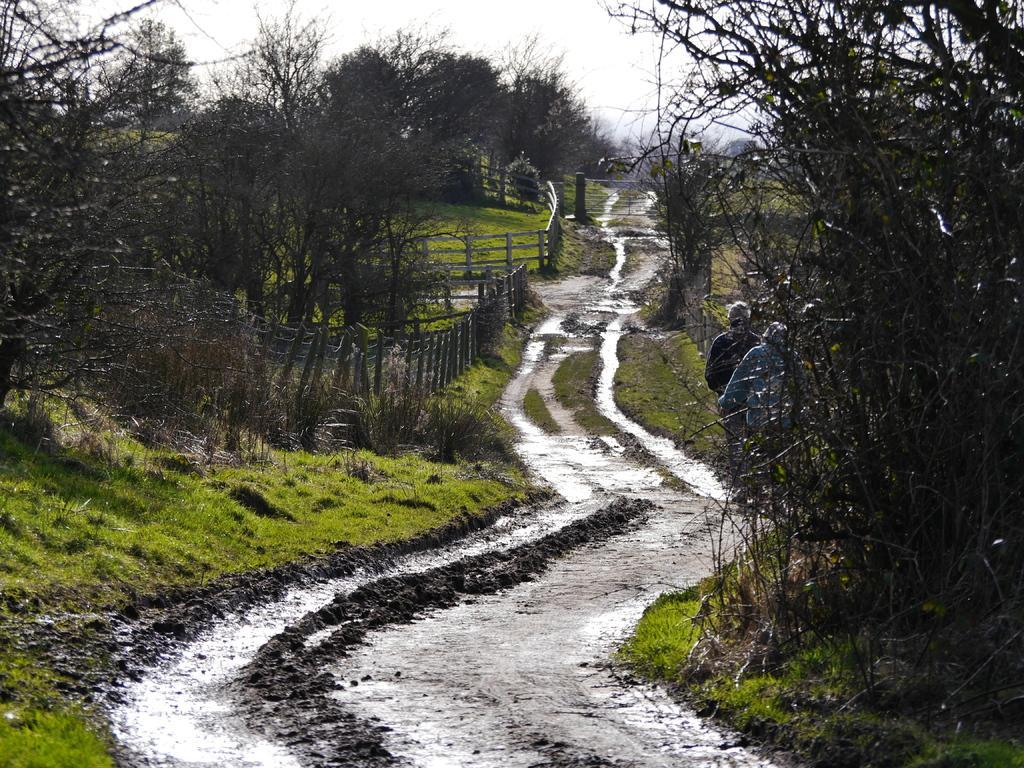Can you describe this image briefly? In this image, we can see there is a wet road. On both sides of this road, there are trees and grass on the ground. On the left side, there are two fences. On the right side, there are two persons. In the background, there are clouds in the sky. 